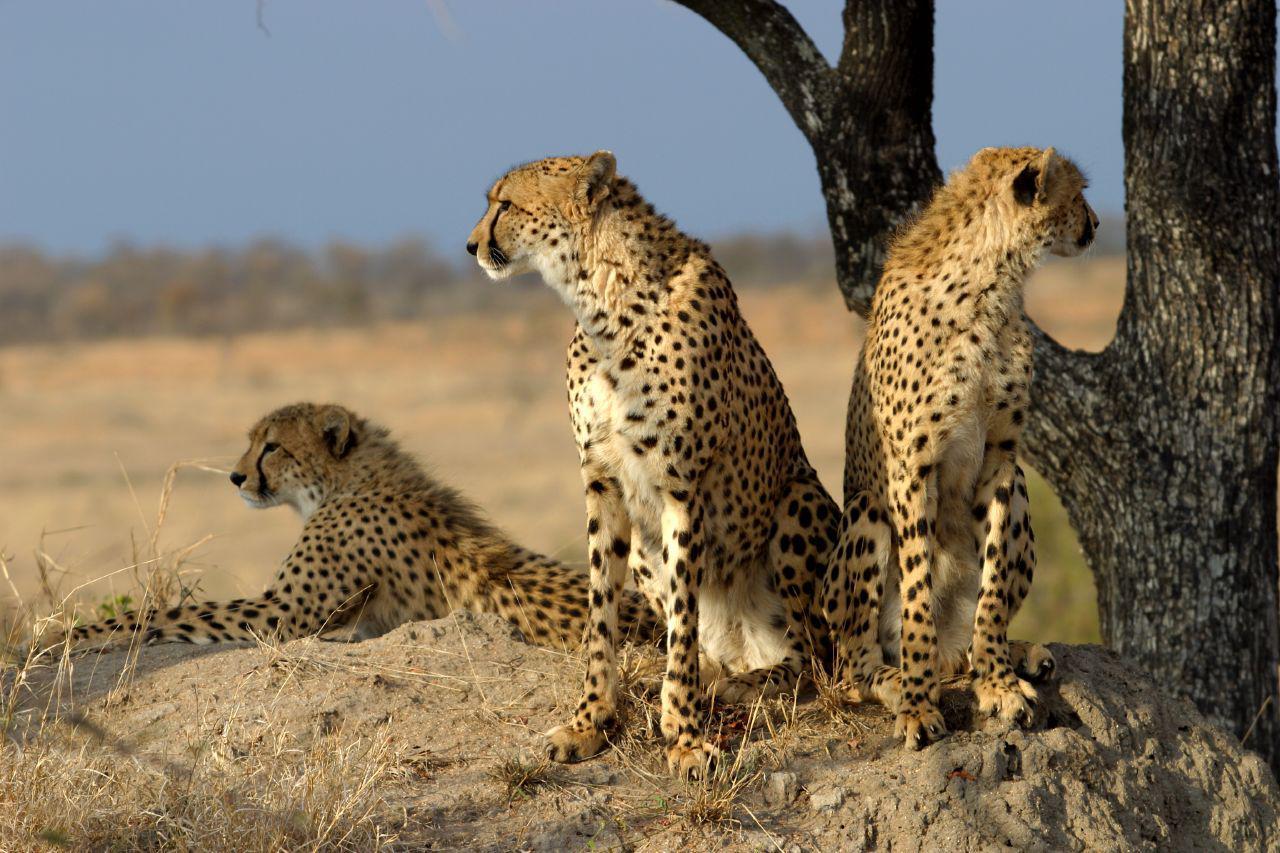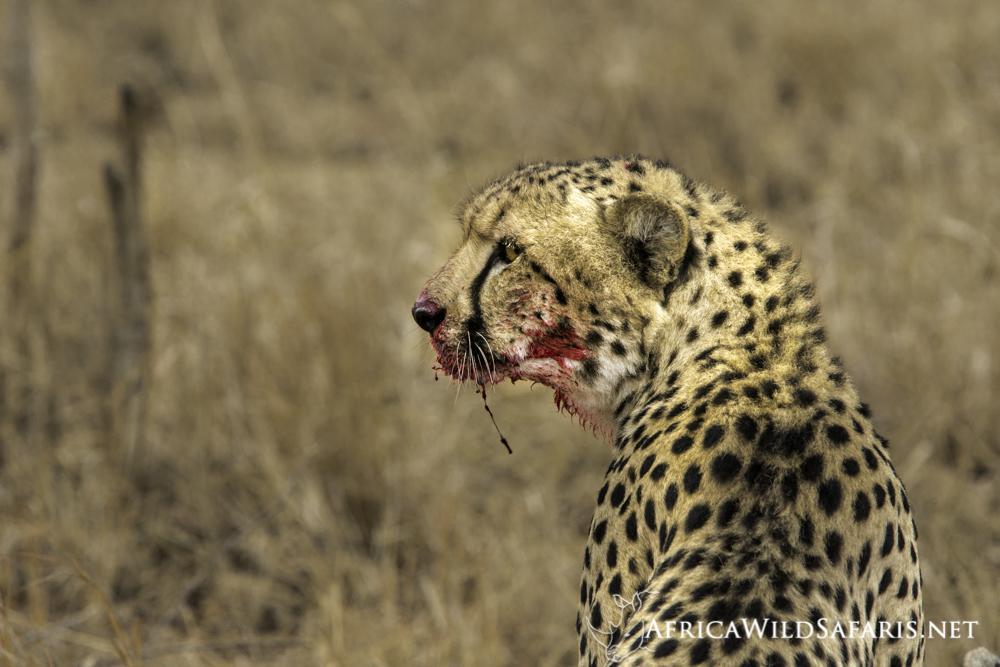The first image is the image on the left, the second image is the image on the right. Analyze the images presented: Is the assertion "At least one image shows a spotted wild cat pursuing a gazelle-type prey animal." valid? Answer yes or no. No. The first image is the image on the left, the second image is the image on the right. For the images displayed, is the sentence "At least one of the animals is chasing its prey." factually correct? Answer yes or no. No. 